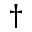<formula> <loc_0><loc_0><loc_500><loc_500>\dagger</formula> 